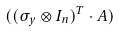<formula> <loc_0><loc_0><loc_500><loc_500>( ( \sigma _ { y } \otimes I _ { n } ) ^ { T } \cdot A )</formula> 